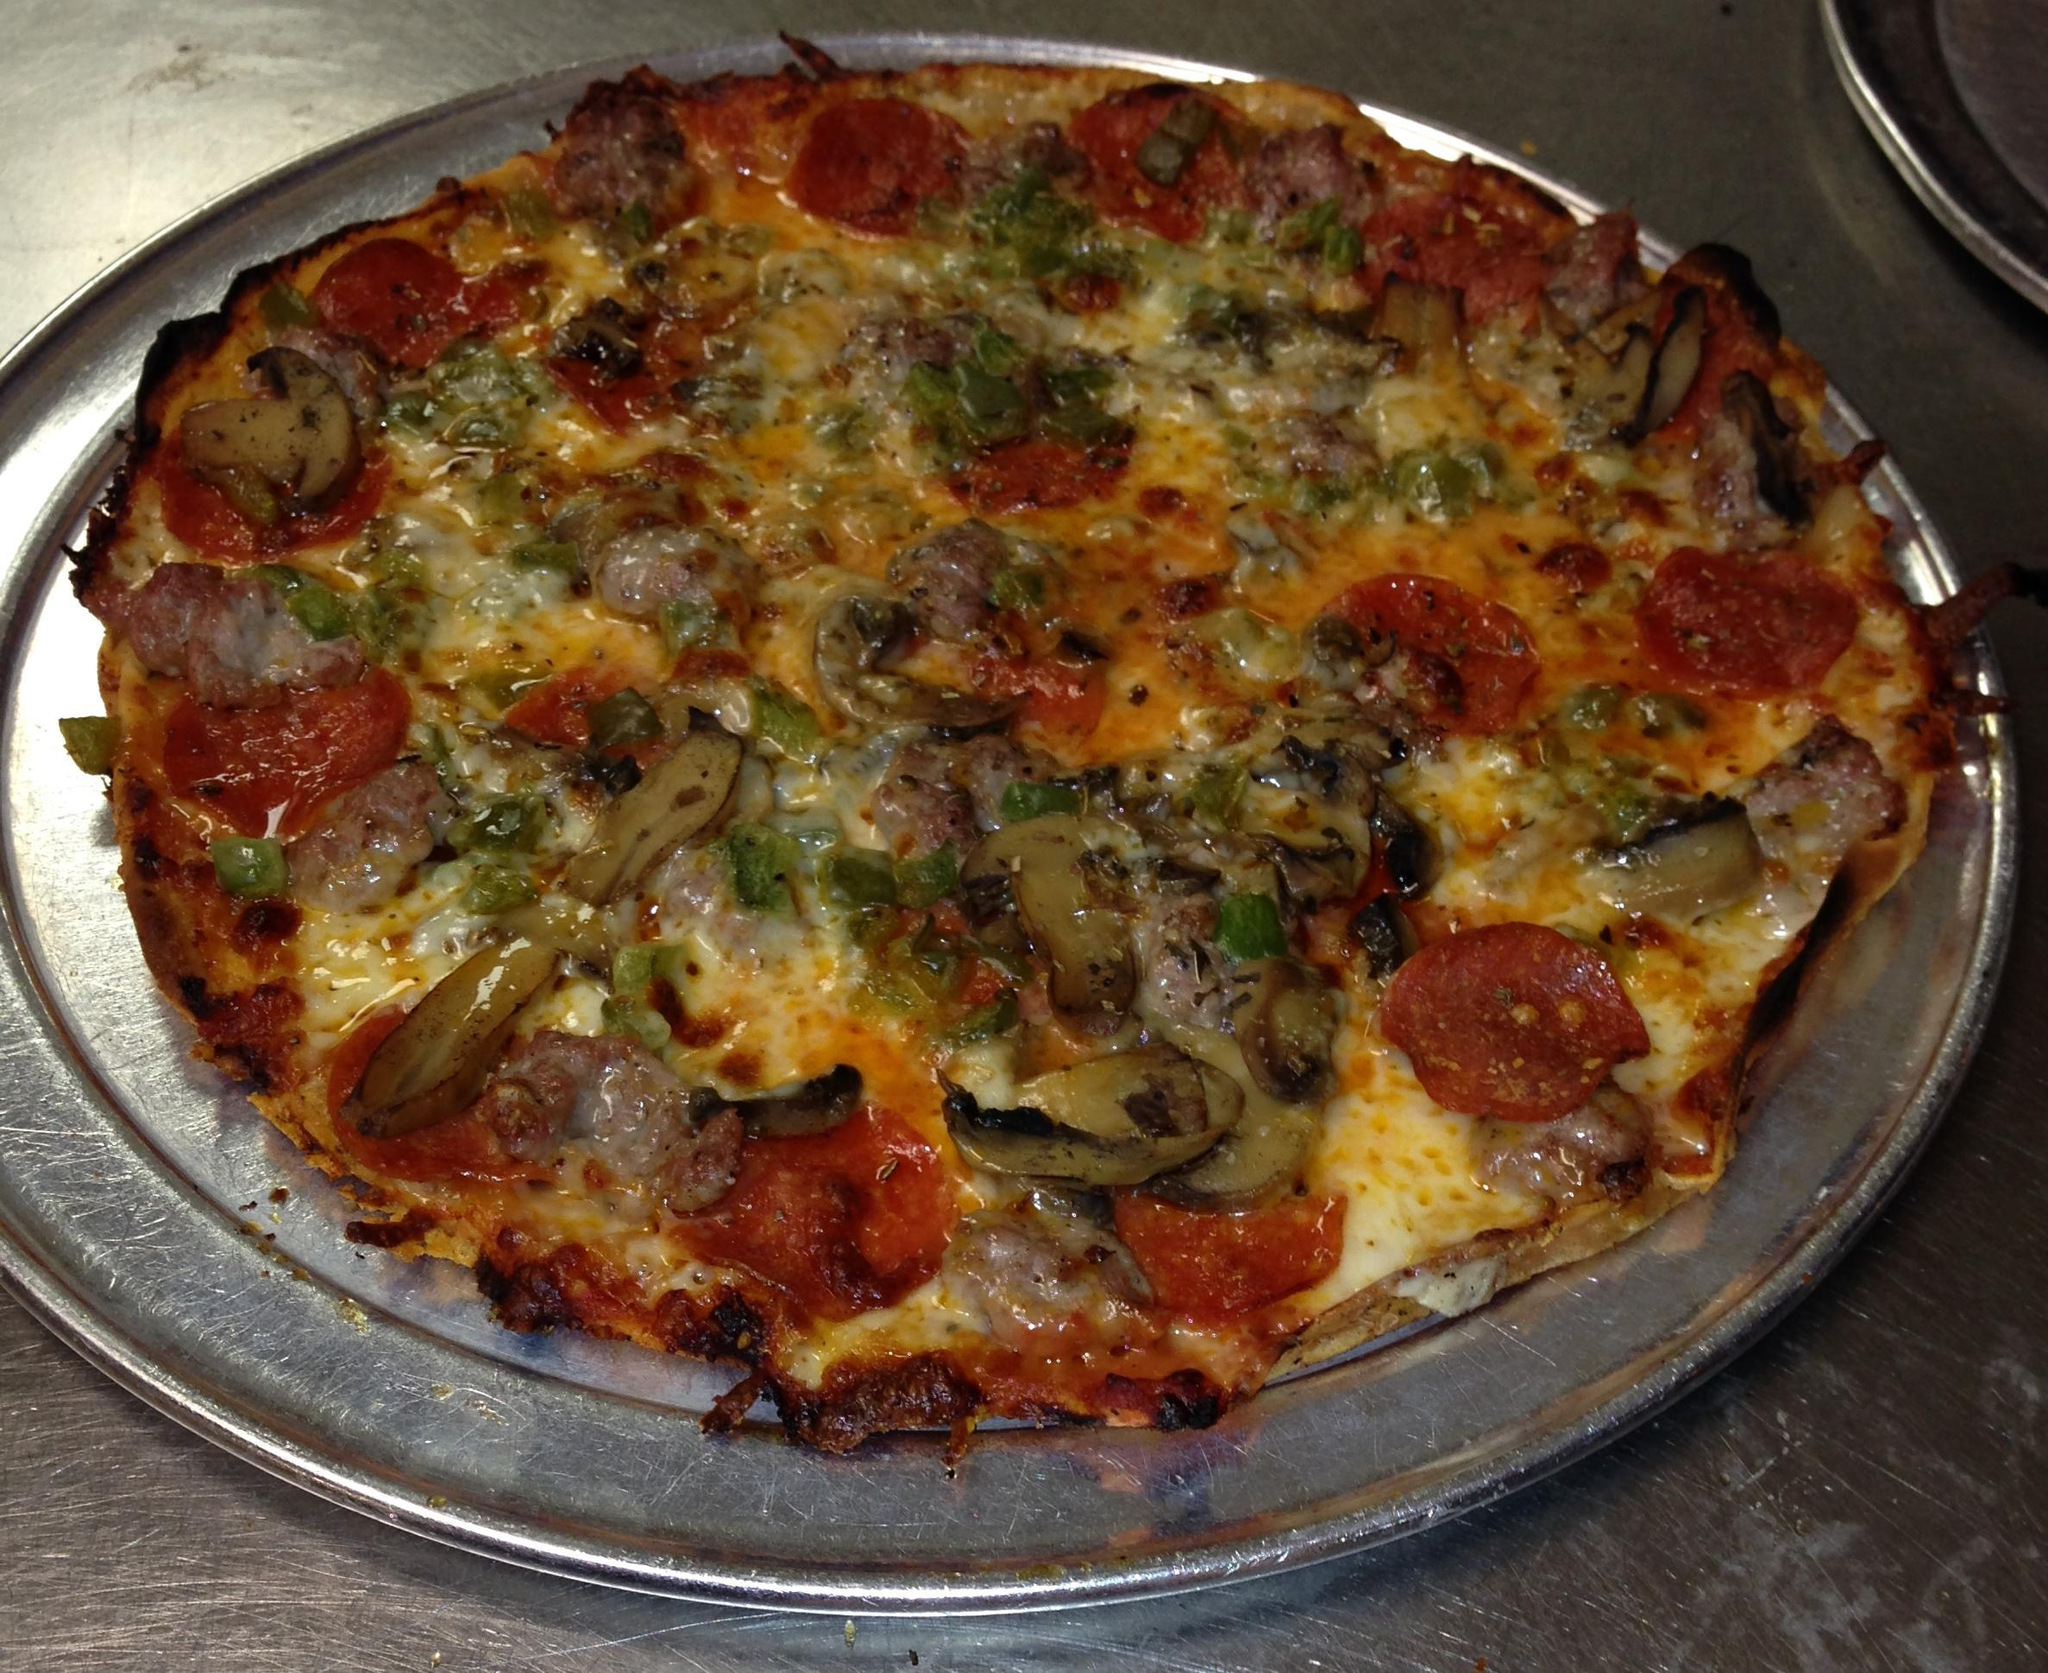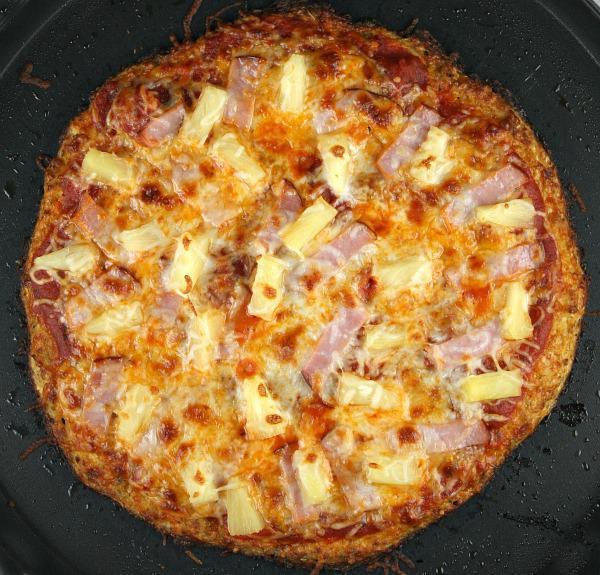The first image is the image on the left, the second image is the image on the right. Assess this claim about the two images: "The pizza in one of the images sits directly on a wooden paddle.". Correct or not? Answer yes or no. No. The first image is the image on the left, the second image is the image on the right. Given the left and right images, does the statement "There are two full circle pizzas." hold true? Answer yes or no. Yes. 